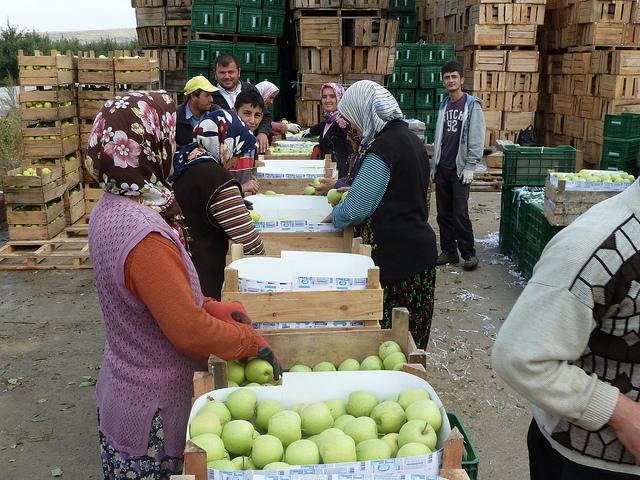Are there any vegetables?
Concise answer only. No. What are being sold?
Keep it brief. Apples. Are apples the only thing for sale?
Quick response, please. Yes. 